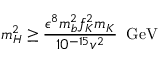Convert formula to latex. <formula><loc_0><loc_0><loc_500><loc_500>m _ { H } ^ { 2 } \geq \frac { \epsilon ^ { 8 } m _ { b } ^ { 2 } f _ { K } ^ { 2 } m _ { K } } { 1 0 ^ { - 1 5 } v ^ { 2 } } \, G e V</formula> 